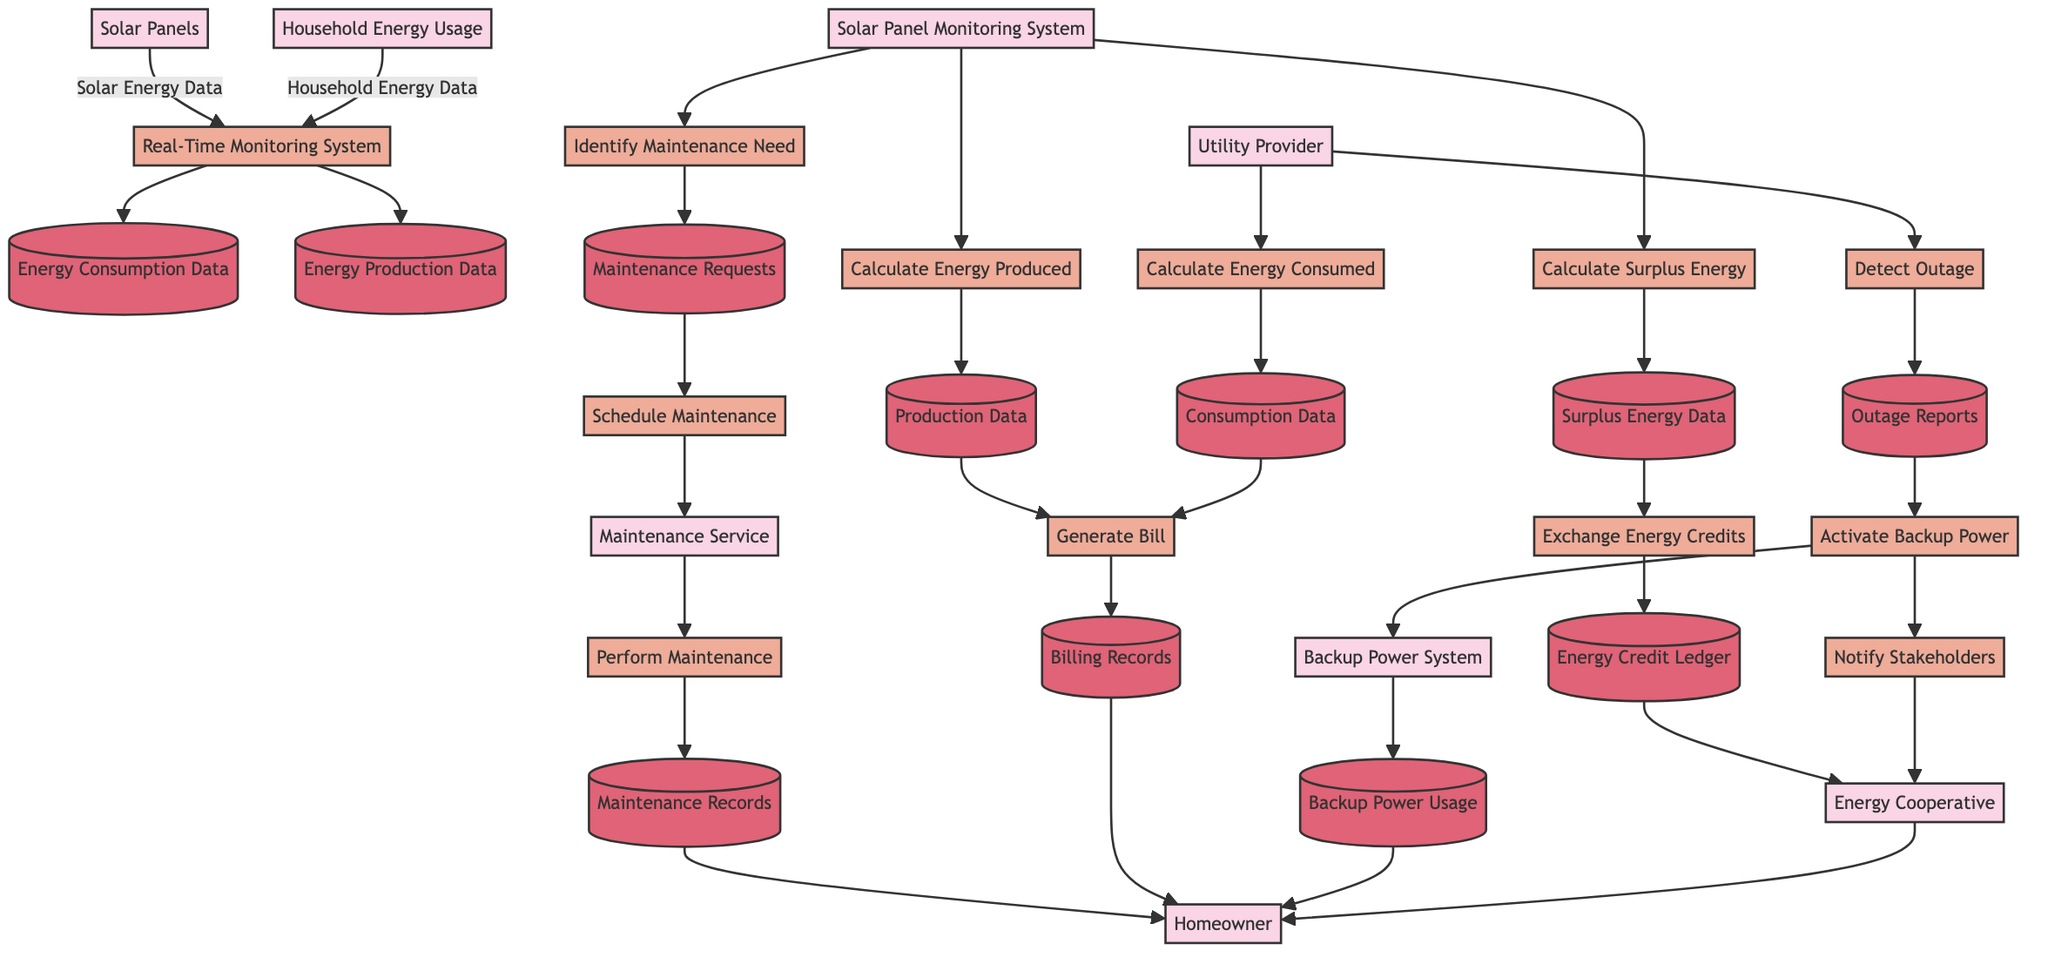What are the main entities involved in the Energy Consumption and Production Tracking process? The diagram specifies three entities: Solar Panels, Household Energy Usage, and Real-Time Monitoring System.
Answer: Solar Panels, Household Energy Usage, Real-Time Monitoring System How many data stores are used in the Cooperative Energy Exchange section? The diagram shows two data stores: Surplus Energy Data and Energy Credit Ledger, which are both linked to processes related to energy credit calculation and exchange.
Answer: 2 What is the first process in the Solar Panel Maintenance Workflow? The diagram indicates that the first process is "Identify Maintenance Need," which is connected to the Solar Panel Monitoring System.
Answer: Identify Maintenance Need Which entity is responsible for generating the bill in the Monthly Utility Billing with Solar Contribution? The entity that generates the bill, as shown in the diagram, is the Utility Provider, which interacts with the processes calculating energy produced and consumed.
Answer: Utility Provider How does the Backup Power System receive data in the Emergency Power Outage Response? The Backup Power System is activated through the process "Activate Backup Power," which follows the detection of the outage, as shown in the flow.
Answer: From the process "Activate Backup Power" What data flows from the House Energy Usage to the Real-Time Monitoring System? The data flow is labeled "Household Energy Data," indicating that this specific data is sent to the Real-Time Monitoring System for tracking purposes.
Answer: Household Energy Data Which data store is used to track the surplus energy calculated in the Cooperative Energy Exchange? The Surplus Energy Data store is used to retain information related to the surplus energy calculated through the "Calculate Surplus Energy" process.
Answer: Surplus Energy Data What is the relationship between the processes "Perform Maintenance" and "Notify Stakeholders"? The relationship is indirect, as "Perform Maintenance" is part of the Solar Panel Maintenance Workflow, while "Notify Stakeholders" is part of the Emergency Power Outage Response process. Both processes involve different entities and focuses but contribute to overall energy management.
Answer: Indirect relationship Which two processes are involved in calculating energy metrics for the utility bill? The processes are "Calculate Energy Produced" and "Calculate Energy Consumed," which gather data from solar panels and the utility provider, respectively, to inform the overall billing.
Answer: Calculate Energy Produced, Calculate Energy Consumed 